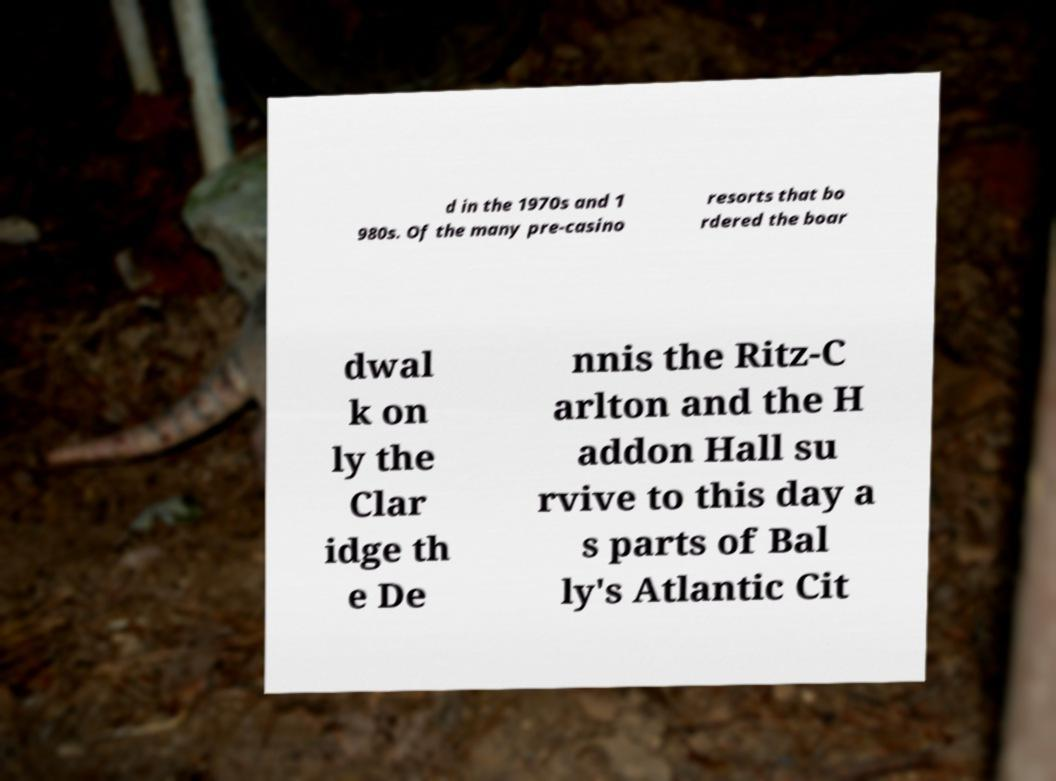I need the written content from this picture converted into text. Can you do that? d in the 1970s and 1 980s. Of the many pre-casino resorts that bo rdered the boar dwal k on ly the Clar idge th e De nnis the Ritz-C arlton and the H addon Hall su rvive to this day a s parts of Bal ly's Atlantic Cit 